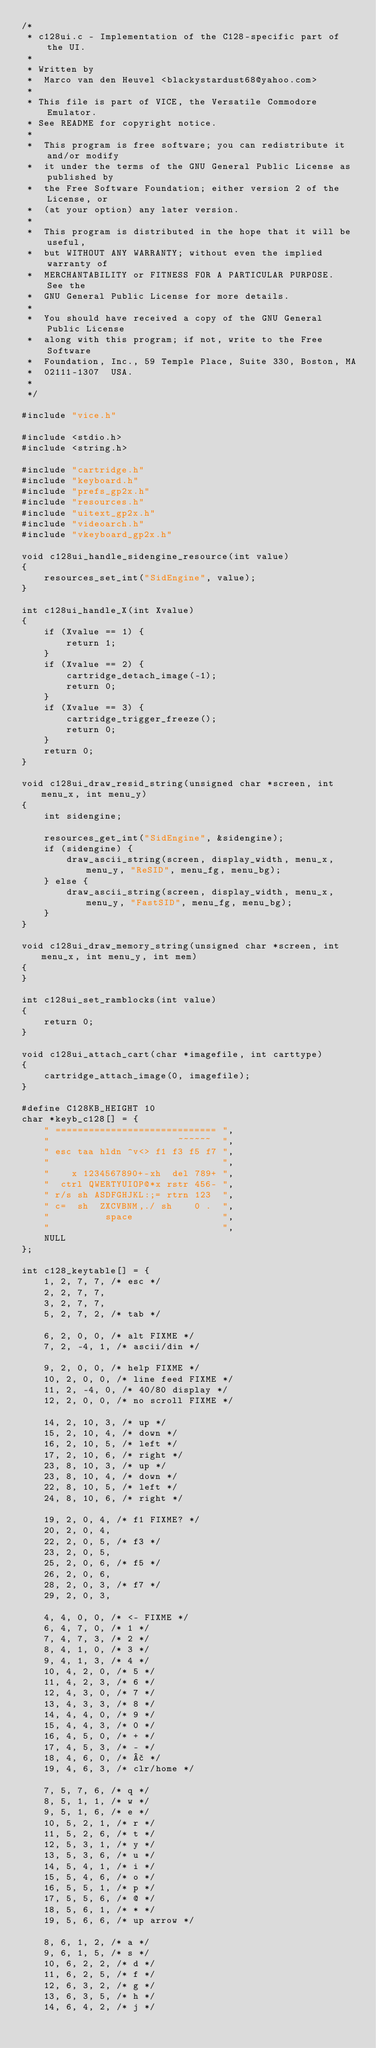<code> <loc_0><loc_0><loc_500><loc_500><_C_>/*
 * c128ui.c - Implementation of the C128-specific part of the UI.
 *
 * Written by
 *  Marco van den Heuvel <blackystardust68@yahoo.com>
 *
 * This file is part of VICE, the Versatile Commodore Emulator.
 * See README for copyright notice.
 *
 *  This program is free software; you can redistribute it and/or modify
 *  it under the terms of the GNU General Public License as published by
 *  the Free Software Foundation; either version 2 of the License, or
 *  (at your option) any later version.
 *
 *  This program is distributed in the hope that it will be useful,
 *  but WITHOUT ANY WARRANTY; without even the implied warranty of
 *  MERCHANTABILITY or FITNESS FOR A PARTICULAR PURPOSE.  See the
 *  GNU General Public License for more details.
 *
 *  You should have received a copy of the GNU General Public License
 *  along with this program; if not, write to the Free Software
 *  Foundation, Inc., 59 Temple Place, Suite 330, Boston, MA
 *  02111-1307  USA.
 *
 */

#include "vice.h"

#include <stdio.h>
#include <string.h>

#include "cartridge.h"
#include "keyboard.h"
#include "prefs_gp2x.h"
#include "resources.h"
#include "uitext_gp2x.h"
#include "videoarch.h"
#include "vkeyboard_gp2x.h"

void c128ui_handle_sidengine_resource(int value)
{
    resources_set_int("SidEngine", value);
}

int c128ui_handle_X(int Xvalue)
{
    if (Xvalue == 1) {
        return 1;
    }
    if (Xvalue == 2) {
        cartridge_detach_image(-1);
        return 0;
    }
    if (Xvalue == 3) {
        cartridge_trigger_freeze();
        return 0;
    }
    return 0;
}

void c128ui_draw_resid_string(unsigned char *screen, int menu_x, int menu_y)
{
    int sidengine;

    resources_get_int("SidEngine", &sidengine);
    if (sidengine) {
        draw_ascii_string(screen, display_width, menu_x, menu_y, "ReSID", menu_fg, menu_bg);
    } else {
        draw_ascii_string(screen, display_width, menu_x, menu_y, "FastSID", menu_fg, menu_bg);
    }
}

void c128ui_draw_memory_string(unsigned char *screen, int menu_x, int menu_y, int mem)
{
}

int c128ui_set_ramblocks(int value)
{
    return 0;
}

void c128ui_attach_cart(char *imagefile, int carttype)
{
    cartridge_attach_image(0, imagefile);
}

#define C128KB_HEIGHT 10
char *keyb_c128[] = {
    " ============================= ",
    "                       ~~~~~~  ",
    " esc taa hldn ^v<> f1 f3 f5 f7 ",
    "                               ",
    "    x 1234567890+-xh  del 789+ ",
    "  ctrl QWERTYUIOP@*x rstr 456- ",
    " r/s sh ASDFGHJKL:;= rtrn 123  ",
    " c=  sh  ZXCVBNM,./ sh    0 .  ",
    "          space                ",
    "                               ",
    NULL
};

int c128_keytable[] = {
    1, 2, 7, 7, /* esc */
    2, 2, 7, 7,
    3, 2, 7, 7,
    5, 2, 7, 2, /* tab */

    6, 2, 0, 0, /* alt FIXME */
    7, 2, -4, 1, /* ascii/din */

    9, 2, 0, 0, /* help FIXME */
    10, 2, 0, 0, /* line feed FIXME */
    11, 2, -4, 0, /* 40/80 display */
    12, 2, 0, 0, /* no scroll FIXME */

    14, 2, 10, 3, /* up */
    15, 2, 10, 4, /* down */
    16, 2, 10, 5, /* left */
    17, 2, 10, 6, /* right */
    23, 8, 10, 3, /* up */
    23, 8, 10, 4, /* down */
    22, 8, 10, 5, /* left */
    24, 8, 10, 6, /* right */

    19, 2, 0, 4, /* f1 FIXME? */
    20, 2, 0, 4, 
    22, 2, 0, 5, /* f3 */
    23, 2, 0, 5,
    25, 2, 0, 6, /* f5 */
    26, 2, 0, 6,
    28, 2, 0, 3, /* f7 */
    29, 2, 0, 3,

    4, 4, 0, 0, /* <- FIXME */
    6, 4, 7, 0, /* 1 */
    7, 4, 7, 3, /* 2 */
    8, 4, 1, 0, /* 3 */
    9, 4, 1, 3, /* 4 */
    10, 4, 2, 0, /* 5 */
    11, 4, 2, 3, /* 6 */
    12, 4, 3, 0, /* 7 */
    13, 4, 3, 3, /* 8 */
    14, 4, 4, 0, /* 9 */
    15, 4, 4, 3, /* 0 */
    16, 4, 5, 0, /* + */
    17, 4, 5, 3, /* - */
    18, 4, 6, 0, /* £ */
    19, 4, 6, 3, /* clr/home */

    7, 5, 7, 6, /* q */
    8, 5, 1, 1, /* w */
    9, 5, 1, 6, /* e */
    10, 5, 2, 1, /* r */
    11, 5, 2, 6, /* t */
    12, 5, 3, 1, /* y */
    13, 5, 3, 6, /* u */
    14, 5, 4, 1, /* i */
    15, 5, 4, 6, /* o */
    16, 5, 5, 1, /* p */
    17, 5, 5, 6, /* @ */
    18, 5, 6, 1, /* * */
    19, 5, 6, 6, /* up arrow */

    8, 6, 1, 2, /* a */
    9, 6, 1, 5, /* s */
    10, 6, 2, 2, /* d */
    11, 6, 2, 5, /* f */
    12, 6, 3, 2, /* g */
    13, 6, 3, 5, /* h */
    14, 6, 4, 2, /* j */</code> 